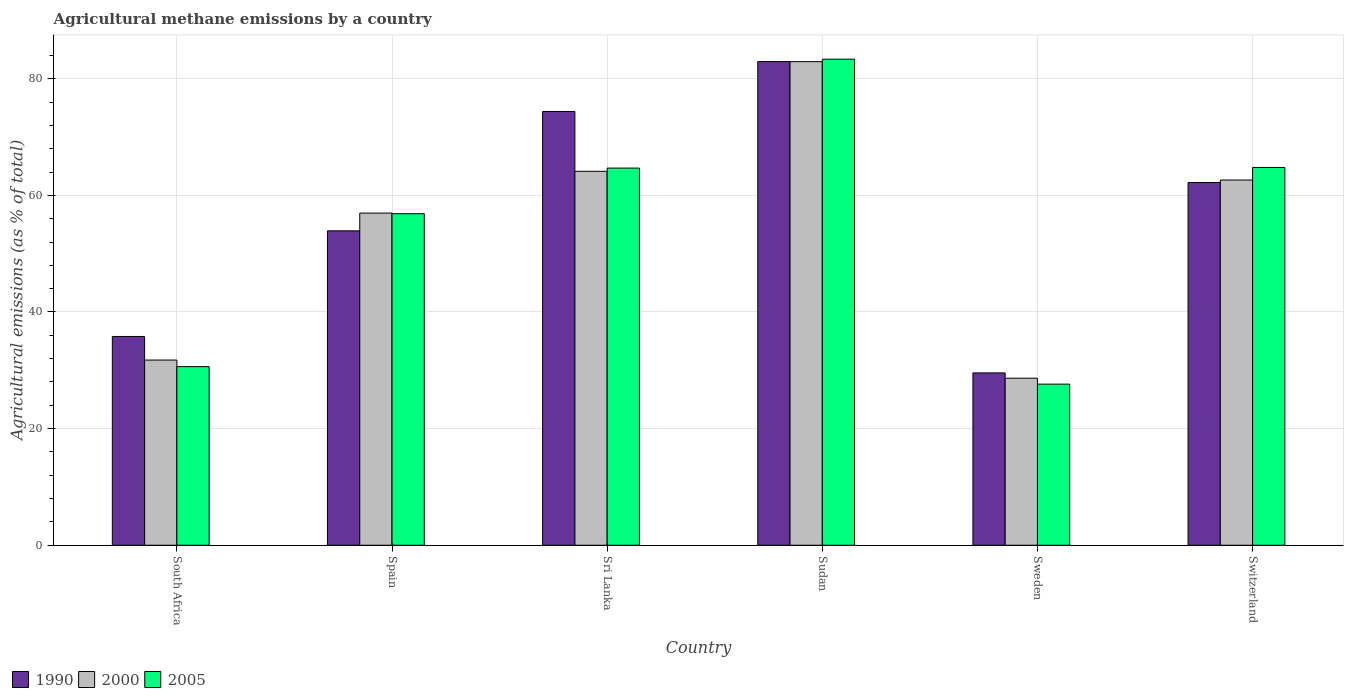How many different coloured bars are there?
Your answer should be compact. 3. How many groups of bars are there?
Your answer should be very brief. 6. Are the number of bars per tick equal to the number of legend labels?
Your answer should be compact. Yes. How many bars are there on the 1st tick from the right?
Ensure brevity in your answer.  3. What is the label of the 3rd group of bars from the left?
Your answer should be very brief. Sri Lanka. In how many cases, is the number of bars for a given country not equal to the number of legend labels?
Your answer should be very brief. 0. What is the amount of agricultural methane emitted in 2000 in Sri Lanka?
Your response must be concise. 64.13. Across all countries, what is the maximum amount of agricultural methane emitted in 1990?
Keep it short and to the point. 82.95. Across all countries, what is the minimum amount of agricultural methane emitted in 2000?
Provide a succinct answer. 28.65. In which country was the amount of agricultural methane emitted in 2005 maximum?
Your response must be concise. Sudan. What is the total amount of agricultural methane emitted in 2000 in the graph?
Your answer should be very brief. 327.06. What is the difference between the amount of agricultural methane emitted in 2000 in Sri Lanka and that in Switzerland?
Keep it short and to the point. 1.5. What is the difference between the amount of agricultural methane emitted in 1990 in Spain and the amount of agricultural methane emitted in 2000 in South Africa?
Ensure brevity in your answer.  22.16. What is the average amount of agricultural methane emitted in 2005 per country?
Provide a short and direct response. 54.66. What is the difference between the amount of agricultural methane emitted of/in 2000 and amount of agricultural methane emitted of/in 2005 in South Africa?
Provide a short and direct response. 1.13. What is the ratio of the amount of agricultural methane emitted in 1990 in Spain to that in Switzerland?
Offer a terse response. 0.87. Is the amount of agricultural methane emitted in 2005 in Sudan less than that in Sweden?
Offer a very short reply. No. Is the difference between the amount of agricultural methane emitted in 2000 in Spain and Switzerland greater than the difference between the amount of agricultural methane emitted in 2005 in Spain and Switzerland?
Ensure brevity in your answer.  Yes. What is the difference between the highest and the second highest amount of agricultural methane emitted in 2005?
Your answer should be compact. 0.11. What is the difference between the highest and the lowest amount of agricultural methane emitted in 2005?
Give a very brief answer. 55.73. What does the 2nd bar from the left in Switzerland represents?
Ensure brevity in your answer.  2000. How many bars are there?
Your response must be concise. 18. How many countries are there in the graph?
Make the answer very short. 6. Are the values on the major ticks of Y-axis written in scientific E-notation?
Provide a succinct answer. No. Does the graph contain grids?
Your answer should be compact. Yes. Where does the legend appear in the graph?
Keep it short and to the point. Bottom left. How many legend labels are there?
Make the answer very short. 3. What is the title of the graph?
Your answer should be compact. Agricultural methane emissions by a country. Does "2002" appear as one of the legend labels in the graph?
Offer a terse response. No. What is the label or title of the X-axis?
Your answer should be very brief. Country. What is the label or title of the Y-axis?
Your answer should be very brief. Agricultural emissions (as % of total). What is the Agricultural emissions (as % of total) of 1990 in South Africa?
Your answer should be compact. 35.8. What is the Agricultural emissions (as % of total) of 2000 in South Africa?
Your answer should be very brief. 31.76. What is the Agricultural emissions (as % of total) of 2005 in South Africa?
Your answer should be very brief. 30.63. What is the Agricultural emissions (as % of total) in 1990 in Spain?
Offer a terse response. 53.92. What is the Agricultural emissions (as % of total) of 2000 in Spain?
Keep it short and to the point. 56.96. What is the Agricultural emissions (as % of total) in 2005 in Spain?
Offer a very short reply. 56.86. What is the Agricultural emissions (as % of total) of 1990 in Sri Lanka?
Provide a succinct answer. 74.39. What is the Agricultural emissions (as % of total) of 2000 in Sri Lanka?
Your response must be concise. 64.13. What is the Agricultural emissions (as % of total) of 2005 in Sri Lanka?
Ensure brevity in your answer.  64.68. What is the Agricultural emissions (as % of total) of 1990 in Sudan?
Your response must be concise. 82.95. What is the Agricultural emissions (as % of total) in 2000 in Sudan?
Your answer should be compact. 82.93. What is the Agricultural emissions (as % of total) in 2005 in Sudan?
Make the answer very short. 83.36. What is the Agricultural emissions (as % of total) of 1990 in Sweden?
Give a very brief answer. 29.55. What is the Agricultural emissions (as % of total) of 2000 in Sweden?
Keep it short and to the point. 28.65. What is the Agricultural emissions (as % of total) in 2005 in Sweden?
Provide a succinct answer. 27.63. What is the Agricultural emissions (as % of total) in 1990 in Switzerland?
Your answer should be compact. 62.2. What is the Agricultural emissions (as % of total) of 2000 in Switzerland?
Offer a very short reply. 62.63. What is the Agricultural emissions (as % of total) of 2005 in Switzerland?
Make the answer very short. 64.79. Across all countries, what is the maximum Agricultural emissions (as % of total) of 1990?
Offer a very short reply. 82.95. Across all countries, what is the maximum Agricultural emissions (as % of total) in 2000?
Your answer should be very brief. 82.93. Across all countries, what is the maximum Agricultural emissions (as % of total) in 2005?
Provide a succinct answer. 83.36. Across all countries, what is the minimum Agricultural emissions (as % of total) in 1990?
Give a very brief answer. 29.55. Across all countries, what is the minimum Agricultural emissions (as % of total) of 2000?
Provide a short and direct response. 28.65. Across all countries, what is the minimum Agricultural emissions (as % of total) in 2005?
Give a very brief answer. 27.63. What is the total Agricultural emissions (as % of total) in 1990 in the graph?
Make the answer very short. 338.82. What is the total Agricultural emissions (as % of total) of 2000 in the graph?
Your response must be concise. 327.06. What is the total Agricultural emissions (as % of total) in 2005 in the graph?
Your response must be concise. 327.94. What is the difference between the Agricultural emissions (as % of total) of 1990 in South Africa and that in Spain?
Provide a succinct answer. -18.11. What is the difference between the Agricultural emissions (as % of total) of 2000 in South Africa and that in Spain?
Provide a short and direct response. -25.2. What is the difference between the Agricultural emissions (as % of total) in 2005 in South Africa and that in Spain?
Ensure brevity in your answer.  -26.23. What is the difference between the Agricultural emissions (as % of total) of 1990 in South Africa and that in Sri Lanka?
Provide a succinct answer. -38.59. What is the difference between the Agricultural emissions (as % of total) in 2000 in South Africa and that in Sri Lanka?
Keep it short and to the point. -32.37. What is the difference between the Agricultural emissions (as % of total) in 2005 in South Africa and that in Sri Lanka?
Your response must be concise. -34.05. What is the difference between the Agricultural emissions (as % of total) in 1990 in South Africa and that in Sudan?
Keep it short and to the point. -47.14. What is the difference between the Agricultural emissions (as % of total) in 2000 in South Africa and that in Sudan?
Give a very brief answer. -51.17. What is the difference between the Agricultural emissions (as % of total) in 2005 in South Africa and that in Sudan?
Your answer should be very brief. -52.73. What is the difference between the Agricultural emissions (as % of total) in 1990 in South Africa and that in Sweden?
Provide a short and direct response. 6.25. What is the difference between the Agricultural emissions (as % of total) of 2000 in South Africa and that in Sweden?
Make the answer very short. 3.11. What is the difference between the Agricultural emissions (as % of total) in 2005 in South Africa and that in Sweden?
Provide a succinct answer. 3. What is the difference between the Agricultural emissions (as % of total) in 1990 in South Africa and that in Switzerland?
Ensure brevity in your answer.  -26.4. What is the difference between the Agricultural emissions (as % of total) in 2000 in South Africa and that in Switzerland?
Give a very brief answer. -30.88. What is the difference between the Agricultural emissions (as % of total) of 2005 in South Africa and that in Switzerland?
Offer a very short reply. -34.16. What is the difference between the Agricultural emissions (as % of total) of 1990 in Spain and that in Sri Lanka?
Your response must be concise. -20.47. What is the difference between the Agricultural emissions (as % of total) of 2000 in Spain and that in Sri Lanka?
Provide a short and direct response. -7.17. What is the difference between the Agricultural emissions (as % of total) of 2005 in Spain and that in Sri Lanka?
Provide a short and direct response. -7.82. What is the difference between the Agricultural emissions (as % of total) of 1990 in Spain and that in Sudan?
Your answer should be compact. -29.03. What is the difference between the Agricultural emissions (as % of total) of 2000 in Spain and that in Sudan?
Offer a terse response. -25.97. What is the difference between the Agricultural emissions (as % of total) in 2005 in Spain and that in Sudan?
Give a very brief answer. -26.5. What is the difference between the Agricultural emissions (as % of total) of 1990 in Spain and that in Sweden?
Give a very brief answer. 24.36. What is the difference between the Agricultural emissions (as % of total) of 2000 in Spain and that in Sweden?
Offer a terse response. 28.32. What is the difference between the Agricultural emissions (as % of total) in 2005 in Spain and that in Sweden?
Your answer should be very brief. 29.23. What is the difference between the Agricultural emissions (as % of total) of 1990 in Spain and that in Switzerland?
Provide a succinct answer. -8.29. What is the difference between the Agricultural emissions (as % of total) of 2000 in Spain and that in Switzerland?
Offer a terse response. -5.67. What is the difference between the Agricultural emissions (as % of total) of 2005 in Spain and that in Switzerland?
Offer a very short reply. -7.93. What is the difference between the Agricultural emissions (as % of total) of 1990 in Sri Lanka and that in Sudan?
Offer a very short reply. -8.56. What is the difference between the Agricultural emissions (as % of total) of 2000 in Sri Lanka and that in Sudan?
Give a very brief answer. -18.8. What is the difference between the Agricultural emissions (as % of total) of 2005 in Sri Lanka and that in Sudan?
Offer a terse response. -18.68. What is the difference between the Agricultural emissions (as % of total) of 1990 in Sri Lanka and that in Sweden?
Provide a succinct answer. 44.84. What is the difference between the Agricultural emissions (as % of total) in 2000 in Sri Lanka and that in Sweden?
Make the answer very short. 35.48. What is the difference between the Agricultural emissions (as % of total) in 2005 in Sri Lanka and that in Sweden?
Your answer should be compact. 37.05. What is the difference between the Agricultural emissions (as % of total) in 1990 in Sri Lanka and that in Switzerland?
Your answer should be very brief. 12.19. What is the difference between the Agricultural emissions (as % of total) in 2000 in Sri Lanka and that in Switzerland?
Provide a short and direct response. 1.5. What is the difference between the Agricultural emissions (as % of total) in 2005 in Sri Lanka and that in Switzerland?
Provide a succinct answer. -0.11. What is the difference between the Agricultural emissions (as % of total) of 1990 in Sudan and that in Sweden?
Make the answer very short. 53.39. What is the difference between the Agricultural emissions (as % of total) in 2000 in Sudan and that in Sweden?
Offer a terse response. 54.29. What is the difference between the Agricultural emissions (as % of total) of 2005 in Sudan and that in Sweden?
Offer a very short reply. 55.73. What is the difference between the Agricultural emissions (as % of total) of 1990 in Sudan and that in Switzerland?
Provide a succinct answer. 20.74. What is the difference between the Agricultural emissions (as % of total) in 2000 in Sudan and that in Switzerland?
Your answer should be compact. 20.3. What is the difference between the Agricultural emissions (as % of total) in 2005 in Sudan and that in Switzerland?
Your response must be concise. 18.57. What is the difference between the Agricultural emissions (as % of total) of 1990 in Sweden and that in Switzerland?
Offer a terse response. -32.65. What is the difference between the Agricultural emissions (as % of total) of 2000 in Sweden and that in Switzerland?
Your answer should be very brief. -33.99. What is the difference between the Agricultural emissions (as % of total) in 2005 in Sweden and that in Switzerland?
Keep it short and to the point. -37.16. What is the difference between the Agricultural emissions (as % of total) of 1990 in South Africa and the Agricultural emissions (as % of total) of 2000 in Spain?
Make the answer very short. -21.16. What is the difference between the Agricultural emissions (as % of total) of 1990 in South Africa and the Agricultural emissions (as % of total) of 2005 in Spain?
Ensure brevity in your answer.  -21.05. What is the difference between the Agricultural emissions (as % of total) in 2000 in South Africa and the Agricultural emissions (as % of total) in 2005 in Spain?
Give a very brief answer. -25.1. What is the difference between the Agricultural emissions (as % of total) of 1990 in South Africa and the Agricultural emissions (as % of total) of 2000 in Sri Lanka?
Provide a short and direct response. -28.32. What is the difference between the Agricultural emissions (as % of total) in 1990 in South Africa and the Agricultural emissions (as % of total) in 2005 in Sri Lanka?
Keep it short and to the point. -28.88. What is the difference between the Agricultural emissions (as % of total) of 2000 in South Africa and the Agricultural emissions (as % of total) of 2005 in Sri Lanka?
Ensure brevity in your answer.  -32.92. What is the difference between the Agricultural emissions (as % of total) of 1990 in South Africa and the Agricultural emissions (as % of total) of 2000 in Sudan?
Offer a terse response. -47.13. What is the difference between the Agricultural emissions (as % of total) in 1990 in South Africa and the Agricultural emissions (as % of total) in 2005 in Sudan?
Your answer should be compact. -47.55. What is the difference between the Agricultural emissions (as % of total) in 2000 in South Africa and the Agricultural emissions (as % of total) in 2005 in Sudan?
Keep it short and to the point. -51.6. What is the difference between the Agricultural emissions (as % of total) in 1990 in South Africa and the Agricultural emissions (as % of total) in 2000 in Sweden?
Keep it short and to the point. 7.16. What is the difference between the Agricultural emissions (as % of total) in 1990 in South Africa and the Agricultural emissions (as % of total) in 2005 in Sweden?
Your response must be concise. 8.17. What is the difference between the Agricultural emissions (as % of total) of 2000 in South Africa and the Agricultural emissions (as % of total) of 2005 in Sweden?
Make the answer very short. 4.13. What is the difference between the Agricultural emissions (as % of total) of 1990 in South Africa and the Agricultural emissions (as % of total) of 2000 in Switzerland?
Ensure brevity in your answer.  -26.83. What is the difference between the Agricultural emissions (as % of total) of 1990 in South Africa and the Agricultural emissions (as % of total) of 2005 in Switzerland?
Your answer should be compact. -28.98. What is the difference between the Agricultural emissions (as % of total) in 2000 in South Africa and the Agricultural emissions (as % of total) in 2005 in Switzerland?
Make the answer very short. -33.03. What is the difference between the Agricultural emissions (as % of total) in 1990 in Spain and the Agricultural emissions (as % of total) in 2000 in Sri Lanka?
Provide a short and direct response. -10.21. What is the difference between the Agricultural emissions (as % of total) of 1990 in Spain and the Agricultural emissions (as % of total) of 2005 in Sri Lanka?
Your response must be concise. -10.76. What is the difference between the Agricultural emissions (as % of total) in 2000 in Spain and the Agricultural emissions (as % of total) in 2005 in Sri Lanka?
Your answer should be compact. -7.72. What is the difference between the Agricultural emissions (as % of total) of 1990 in Spain and the Agricultural emissions (as % of total) of 2000 in Sudan?
Your answer should be compact. -29.01. What is the difference between the Agricultural emissions (as % of total) in 1990 in Spain and the Agricultural emissions (as % of total) in 2005 in Sudan?
Keep it short and to the point. -29.44. What is the difference between the Agricultural emissions (as % of total) of 2000 in Spain and the Agricultural emissions (as % of total) of 2005 in Sudan?
Provide a short and direct response. -26.4. What is the difference between the Agricultural emissions (as % of total) in 1990 in Spain and the Agricultural emissions (as % of total) in 2000 in Sweden?
Your response must be concise. 25.27. What is the difference between the Agricultural emissions (as % of total) of 1990 in Spain and the Agricultural emissions (as % of total) of 2005 in Sweden?
Provide a short and direct response. 26.29. What is the difference between the Agricultural emissions (as % of total) in 2000 in Spain and the Agricultural emissions (as % of total) in 2005 in Sweden?
Make the answer very short. 29.33. What is the difference between the Agricultural emissions (as % of total) in 1990 in Spain and the Agricultural emissions (as % of total) in 2000 in Switzerland?
Provide a short and direct response. -8.71. What is the difference between the Agricultural emissions (as % of total) of 1990 in Spain and the Agricultural emissions (as % of total) of 2005 in Switzerland?
Keep it short and to the point. -10.87. What is the difference between the Agricultural emissions (as % of total) of 2000 in Spain and the Agricultural emissions (as % of total) of 2005 in Switzerland?
Your answer should be compact. -7.83. What is the difference between the Agricultural emissions (as % of total) in 1990 in Sri Lanka and the Agricultural emissions (as % of total) in 2000 in Sudan?
Ensure brevity in your answer.  -8.54. What is the difference between the Agricultural emissions (as % of total) in 1990 in Sri Lanka and the Agricultural emissions (as % of total) in 2005 in Sudan?
Provide a succinct answer. -8.97. What is the difference between the Agricultural emissions (as % of total) in 2000 in Sri Lanka and the Agricultural emissions (as % of total) in 2005 in Sudan?
Give a very brief answer. -19.23. What is the difference between the Agricultural emissions (as % of total) in 1990 in Sri Lanka and the Agricultural emissions (as % of total) in 2000 in Sweden?
Give a very brief answer. 45.74. What is the difference between the Agricultural emissions (as % of total) of 1990 in Sri Lanka and the Agricultural emissions (as % of total) of 2005 in Sweden?
Offer a very short reply. 46.76. What is the difference between the Agricultural emissions (as % of total) in 2000 in Sri Lanka and the Agricultural emissions (as % of total) in 2005 in Sweden?
Provide a short and direct response. 36.5. What is the difference between the Agricultural emissions (as % of total) in 1990 in Sri Lanka and the Agricultural emissions (as % of total) in 2000 in Switzerland?
Provide a short and direct response. 11.76. What is the difference between the Agricultural emissions (as % of total) in 1990 in Sri Lanka and the Agricultural emissions (as % of total) in 2005 in Switzerland?
Ensure brevity in your answer.  9.6. What is the difference between the Agricultural emissions (as % of total) in 2000 in Sri Lanka and the Agricultural emissions (as % of total) in 2005 in Switzerland?
Your answer should be compact. -0.66. What is the difference between the Agricultural emissions (as % of total) of 1990 in Sudan and the Agricultural emissions (as % of total) of 2000 in Sweden?
Your answer should be compact. 54.3. What is the difference between the Agricultural emissions (as % of total) of 1990 in Sudan and the Agricultural emissions (as % of total) of 2005 in Sweden?
Your answer should be very brief. 55.32. What is the difference between the Agricultural emissions (as % of total) in 2000 in Sudan and the Agricultural emissions (as % of total) in 2005 in Sweden?
Offer a terse response. 55.3. What is the difference between the Agricultural emissions (as % of total) of 1990 in Sudan and the Agricultural emissions (as % of total) of 2000 in Switzerland?
Provide a succinct answer. 20.31. What is the difference between the Agricultural emissions (as % of total) in 1990 in Sudan and the Agricultural emissions (as % of total) in 2005 in Switzerland?
Your answer should be very brief. 18.16. What is the difference between the Agricultural emissions (as % of total) of 2000 in Sudan and the Agricultural emissions (as % of total) of 2005 in Switzerland?
Offer a very short reply. 18.14. What is the difference between the Agricultural emissions (as % of total) of 1990 in Sweden and the Agricultural emissions (as % of total) of 2000 in Switzerland?
Offer a terse response. -33.08. What is the difference between the Agricultural emissions (as % of total) of 1990 in Sweden and the Agricultural emissions (as % of total) of 2005 in Switzerland?
Provide a succinct answer. -35.23. What is the difference between the Agricultural emissions (as % of total) in 2000 in Sweden and the Agricultural emissions (as % of total) in 2005 in Switzerland?
Ensure brevity in your answer.  -36.14. What is the average Agricultural emissions (as % of total) of 1990 per country?
Your answer should be compact. 56.47. What is the average Agricultural emissions (as % of total) of 2000 per country?
Offer a terse response. 54.51. What is the average Agricultural emissions (as % of total) in 2005 per country?
Provide a short and direct response. 54.66. What is the difference between the Agricultural emissions (as % of total) in 1990 and Agricultural emissions (as % of total) in 2000 in South Africa?
Your response must be concise. 4.05. What is the difference between the Agricultural emissions (as % of total) of 1990 and Agricultural emissions (as % of total) of 2005 in South Africa?
Provide a succinct answer. 5.18. What is the difference between the Agricultural emissions (as % of total) in 2000 and Agricultural emissions (as % of total) in 2005 in South Africa?
Give a very brief answer. 1.13. What is the difference between the Agricultural emissions (as % of total) of 1990 and Agricultural emissions (as % of total) of 2000 in Spain?
Provide a short and direct response. -3.04. What is the difference between the Agricultural emissions (as % of total) in 1990 and Agricultural emissions (as % of total) in 2005 in Spain?
Keep it short and to the point. -2.94. What is the difference between the Agricultural emissions (as % of total) of 2000 and Agricultural emissions (as % of total) of 2005 in Spain?
Offer a very short reply. 0.1. What is the difference between the Agricultural emissions (as % of total) in 1990 and Agricultural emissions (as % of total) in 2000 in Sri Lanka?
Provide a short and direct response. 10.26. What is the difference between the Agricultural emissions (as % of total) in 1990 and Agricultural emissions (as % of total) in 2005 in Sri Lanka?
Give a very brief answer. 9.71. What is the difference between the Agricultural emissions (as % of total) of 2000 and Agricultural emissions (as % of total) of 2005 in Sri Lanka?
Make the answer very short. -0.55. What is the difference between the Agricultural emissions (as % of total) of 1990 and Agricultural emissions (as % of total) of 2000 in Sudan?
Your answer should be compact. 0.01. What is the difference between the Agricultural emissions (as % of total) of 1990 and Agricultural emissions (as % of total) of 2005 in Sudan?
Your response must be concise. -0.41. What is the difference between the Agricultural emissions (as % of total) of 2000 and Agricultural emissions (as % of total) of 2005 in Sudan?
Your response must be concise. -0.43. What is the difference between the Agricultural emissions (as % of total) of 1990 and Agricultural emissions (as % of total) of 2000 in Sweden?
Your answer should be very brief. 0.91. What is the difference between the Agricultural emissions (as % of total) of 1990 and Agricultural emissions (as % of total) of 2005 in Sweden?
Your answer should be very brief. 1.93. What is the difference between the Agricultural emissions (as % of total) of 2000 and Agricultural emissions (as % of total) of 2005 in Sweden?
Give a very brief answer. 1.02. What is the difference between the Agricultural emissions (as % of total) of 1990 and Agricultural emissions (as % of total) of 2000 in Switzerland?
Ensure brevity in your answer.  -0.43. What is the difference between the Agricultural emissions (as % of total) in 1990 and Agricultural emissions (as % of total) in 2005 in Switzerland?
Offer a terse response. -2.58. What is the difference between the Agricultural emissions (as % of total) of 2000 and Agricultural emissions (as % of total) of 2005 in Switzerland?
Keep it short and to the point. -2.15. What is the ratio of the Agricultural emissions (as % of total) in 1990 in South Africa to that in Spain?
Offer a terse response. 0.66. What is the ratio of the Agricultural emissions (as % of total) of 2000 in South Africa to that in Spain?
Give a very brief answer. 0.56. What is the ratio of the Agricultural emissions (as % of total) of 2005 in South Africa to that in Spain?
Keep it short and to the point. 0.54. What is the ratio of the Agricultural emissions (as % of total) in 1990 in South Africa to that in Sri Lanka?
Provide a succinct answer. 0.48. What is the ratio of the Agricultural emissions (as % of total) in 2000 in South Africa to that in Sri Lanka?
Give a very brief answer. 0.5. What is the ratio of the Agricultural emissions (as % of total) in 2005 in South Africa to that in Sri Lanka?
Provide a succinct answer. 0.47. What is the ratio of the Agricultural emissions (as % of total) in 1990 in South Africa to that in Sudan?
Ensure brevity in your answer.  0.43. What is the ratio of the Agricultural emissions (as % of total) of 2000 in South Africa to that in Sudan?
Keep it short and to the point. 0.38. What is the ratio of the Agricultural emissions (as % of total) of 2005 in South Africa to that in Sudan?
Offer a very short reply. 0.37. What is the ratio of the Agricultural emissions (as % of total) of 1990 in South Africa to that in Sweden?
Your answer should be compact. 1.21. What is the ratio of the Agricultural emissions (as % of total) of 2000 in South Africa to that in Sweden?
Your response must be concise. 1.11. What is the ratio of the Agricultural emissions (as % of total) of 2005 in South Africa to that in Sweden?
Your answer should be very brief. 1.11. What is the ratio of the Agricultural emissions (as % of total) in 1990 in South Africa to that in Switzerland?
Your answer should be very brief. 0.58. What is the ratio of the Agricultural emissions (as % of total) of 2000 in South Africa to that in Switzerland?
Provide a succinct answer. 0.51. What is the ratio of the Agricultural emissions (as % of total) in 2005 in South Africa to that in Switzerland?
Provide a short and direct response. 0.47. What is the ratio of the Agricultural emissions (as % of total) of 1990 in Spain to that in Sri Lanka?
Make the answer very short. 0.72. What is the ratio of the Agricultural emissions (as % of total) in 2000 in Spain to that in Sri Lanka?
Make the answer very short. 0.89. What is the ratio of the Agricultural emissions (as % of total) of 2005 in Spain to that in Sri Lanka?
Keep it short and to the point. 0.88. What is the ratio of the Agricultural emissions (as % of total) of 1990 in Spain to that in Sudan?
Give a very brief answer. 0.65. What is the ratio of the Agricultural emissions (as % of total) in 2000 in Spain to that in Sudan?
Ensure brevity in your answer.  0.69. What is the ratio of the Agricultural emissions (as % of total) of 2005 in Spain to that in Sudan?
Your answer should be very brief. 0.68. What is the ratio of the Agricultural emissions (as % of total) in 1990 in Spain to that in Sweden?
Ensure brevity in your answer.  1.82. What is the ratio of the Agricultural emissions (as % of total) in 2000 in Spain to that in Sweden?
Offer a terse response. 1.99. What is the ratio of the Agricultural emissions (as % of total) of 2005 in Spain to that in Sweden?
Your answer should be compact. 2.06. What is the ratio of the Agricultural emissions (as % of total) of 1990 in Spain to that in Switzerland?
Provide a short and direct response. 0.87. What is the ratio of the Agricultural emissions (as % of total) in 2000 in Spain to that in Switzerland?
Give a very brief answer. 0.91. What is the ratio of the Agricultural emissions (as % of total) in 2005 in Spain to that in Switzerland?
Provide a short and direct response. 0.88. What is the ratio of the Agricultural emissions (as % of total) in 1990 in Sri Lanka to that in Sudan?
Provide a succinct answer. 0.9. What is the ratio of the Agricultural emissions (as % of total) in 2000 in Sri Lanka to that in Sudan?
Your response must be concise. 0.77. What is the ratio of the Agricultural emissions (as % of total) in 2005 in Sri Lanka to that in Sudan?
Provide a succinct answer. 0.78. What is the ratio of the Agricultural emissions (as % of total) of 1990 in Sri Lanka to that in Sweden?
Give a very brief answer. 2.52. What is the ratio of the Agricultural emissions (as % of total) in 2000 in Sri Lanka to that in Sweden?
Your answer should be very brief. 2.24. What is the ratio of the Agricultural emissions (as % of total) in 2005 in Sri Lanka to that in Sweden?
Ensure brevity in your answer.  2.34. What is the ratio of the Agricultural emissions (as % of total) of 1990 in Sri Lanka to that in Switzerland?
Give a very brief answer. 1.2. What is the ratio of the Agricultural emissions (as % of total) in 2000 in Sri Lanka to that in Switzerland?
Provide a short and direct response. 1.02. What is the ratio of the Agricultural emissions (as % of total) in 2005 in Sri Lanka to that in Switzerland?
Your answer should be very brief. 1. What is the ratio of the Agricultural emissions (as % of total) of 1990 in Sudan to that in Sweden?
Your response must be concise. 2.81. What is the ratio of the Agricultural emissions (as % of total) of 2000 in Sudan to that in Sweden?
Ensure brevity in your answer.  2.9. What is the ratio of the Agricultural emissions (as % of total) in 2005 in Sudan to that in Sweden?
Keep it short and to the point. 3.02. What is the ratio of the Agricultural emissions (as % of total) of 1990 in Sudan to that in Switzerland?
Ensure brevity in your answer.  1.33. What is the ratio of the Agricultural emissions (as % of total) of 2000 in Sudan to that in Switzerland?
Your response must be concise. 1.32. What is the ratio of the Agricultural emissions (as % of total) of 2005 in Sudan to that in Switzerland?
Provide a short and direct response. 1.29. What is the ratio of the Agricultural emissions (as % of total) of 1990 in Sweden to that in Switzerland?
Provide a short and direct response. 0.48. What is the ratio of the Agricultural emissions (as % of total) in 2000 in Sweden to that in Switzerland?
Your response must be concise. 0.46. What is the ratio of the Agricultural emissions (as % of total) of 2005 in Sweden to that in Switzerland?
Make the answer very short. 0.43. What is the difference between the highest and the second highest Agricultural emissions (as % of total) in 1990?
Ensure brevity in your answer.  8.56. What is the difference between the highest and the second highest Agricultural emissions (as % of total) in 2000?
Keep it short and to the point. 18.8. What is the difference between the highest and the second highest Agricultural emissions (as % of total) in 2005?
Your response must be concise. 18.57. What is the difference between the highest and the lowest Agricultural emissions (as % of total) in 1990?
Keep it short and to the point. 53.39. What is the difference between the highest and the lowest Agricultural emissions (as % of total) of 2000?
Provide a short and direct response. 54.29. What is the difference between the highest and the lowest Agricultural emissions (as % of total) of 2005?
Your response must be concise. 55.73. 